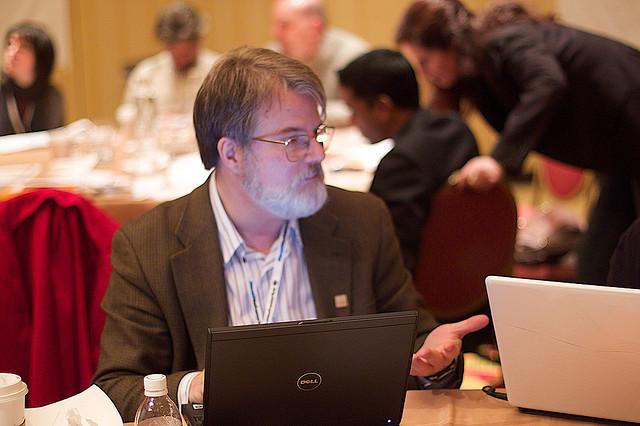What color is the jacket on the chair?
Short answer required. Red. Is this person wearing glasses?
Be succinct. Yes. What is the red thing in the foreground of the image?
Write a very short answer. Jacket. IS this person a doctor?
Answer briefly. No. 